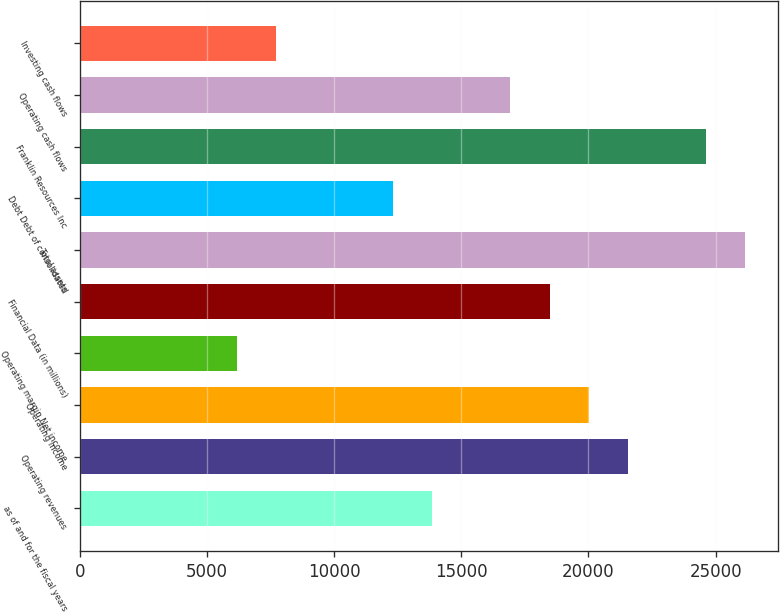Convert chart to OTSL. <chart><loc_0><loc_0><loc_500><loc_500><bar_chart><fcel>as of and for the fiscal years<fcel>Operating revenues<fcel>Operating income<fcel>Operating margin Net income<fcel>Financial Data (in millions)<fcel>Total assets<fcel>Debt Debt of consolidated<fcel>Franklin Resources Inc<fcel>Operating cash flows<fcel>Investing cash flows<nl><fcel>13851.4<fcel>21545.8<fcel>20007<fcel>6156.95<fcel>18468.1<fcel>26162.5<fcel>12312.5<fcel>24623.6<fcel>16929.2<fcel>7695.84<nl></chart> 